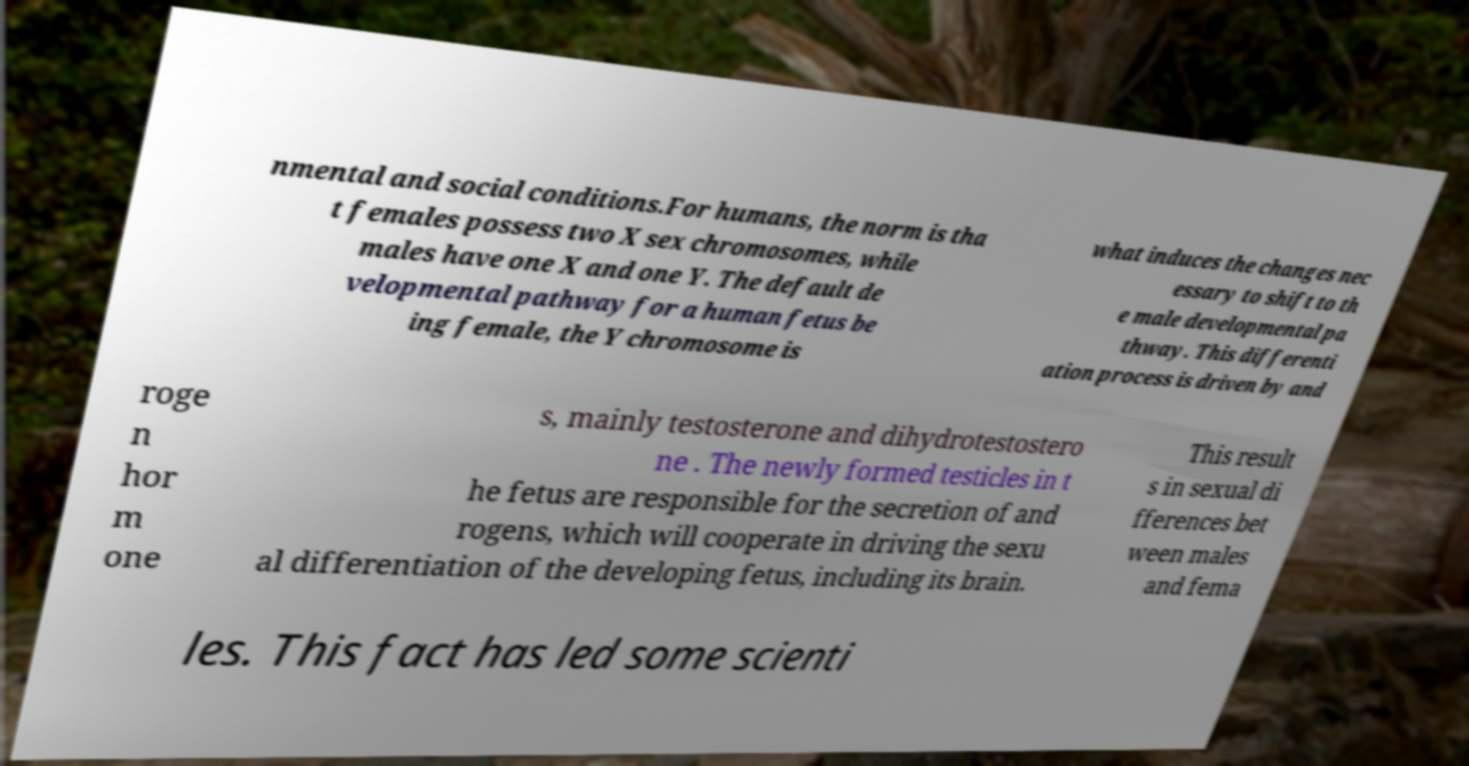What messages or text are displayed in this image? I need them in a readable, typed format. nmental and social conditions.For humans, the norm is tha t females possess two X sex chromosomes, while males have one X and one Y. The default de velopmental pathway for a human fetus be ing female, the Y chromosome is what induces the changes nec essary to shift to th e male developmental pa thway. This differenti ation process is driven by and roge n hor m one s, mainly testosterone and dihydrotestostero ne . The newly formed testicles in t he fetus are responsible for the secretion of and rogens, which will cooperate in driving the sexu al differentiation of the developing fetus, including its brain. This result s in sexual di fferences bet ween males and fema les. This fact has led some scienti 